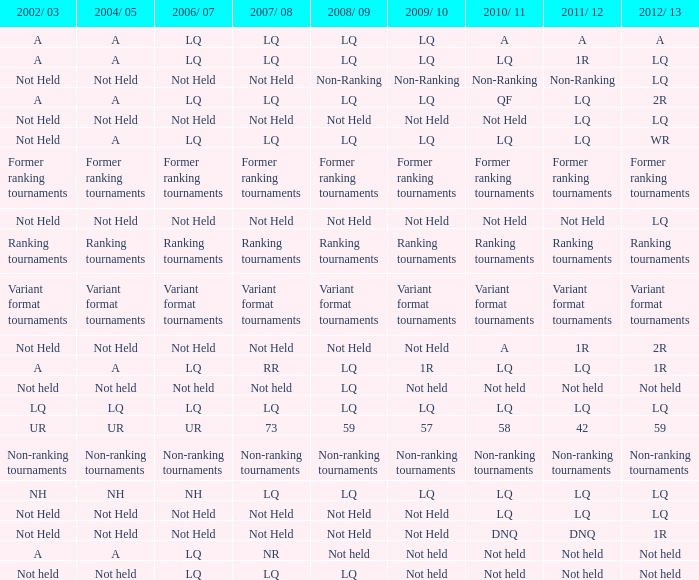Name the 2008/09 with 2004/05 of ranking tournaments Ranking tournaments. 